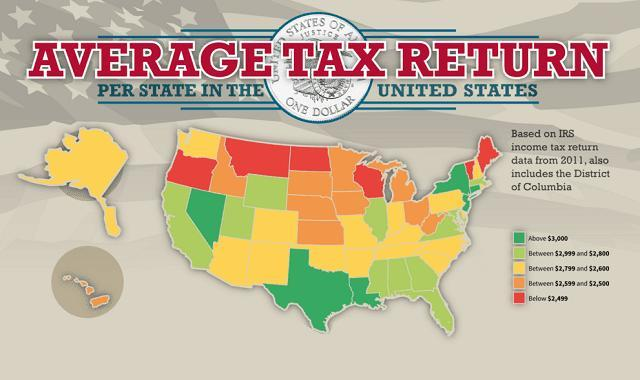How many states have average tax returns Below $2,499 - four, five or six?
Answer the question with a short phrase. six What is the average tax return range for the small group of islands in the south west region? between $2,599 and $2,500 What is the color of the large island on the north west - red, green, black or yellow? yellow 